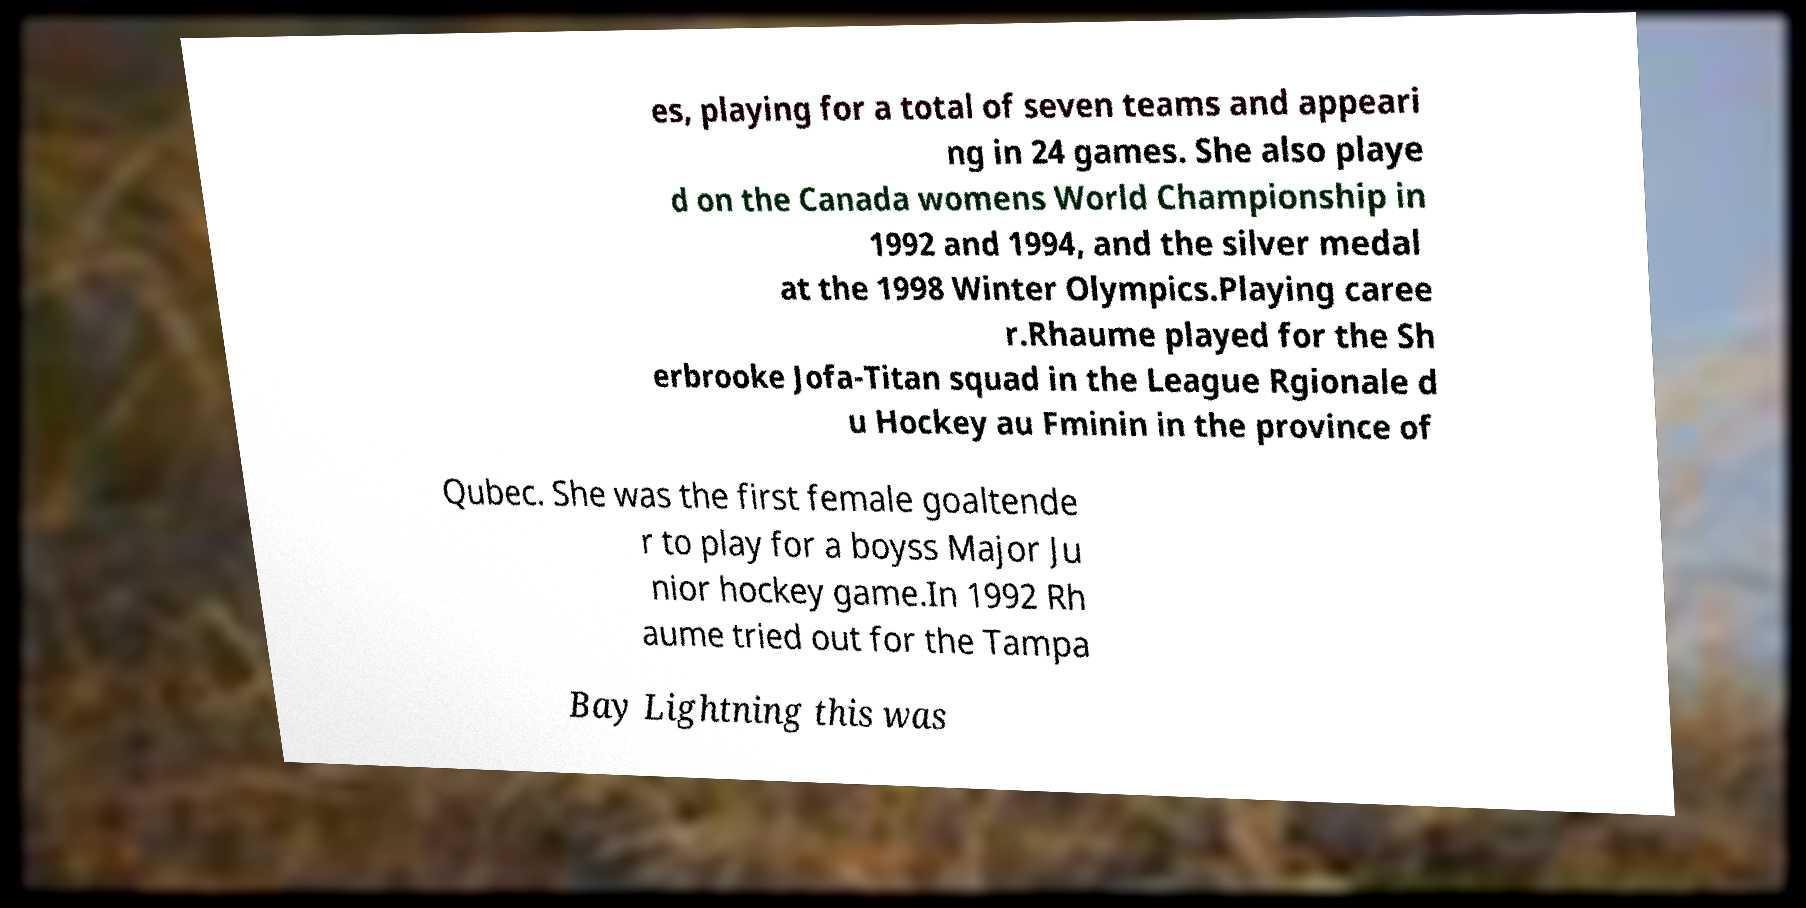Can you accurately transcribe the text from the provided image for me? es, playing for a total of seven teams and appeari ng in 24 games. She also playe d on the Canada womens World Championship in 1992 and 1994, and the silver medal at the 1998 Winter Olympics.Playing caree r.Rhaume played for the Sh erbrooke Jofa-Titan squad in the League Rgionale d u Hockey au Fminin in the province of Qubec. She was the first female goaltende r to play for a boyss Major Ju nior hockey game.In 1992 Rh aume tried out for the Tampa Bay Lightning this was 